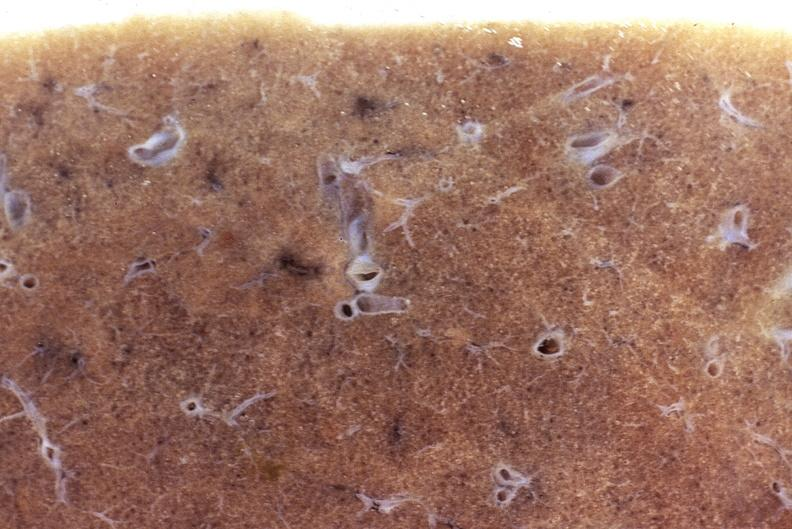s respiratory present?
Answer the question using a single word or phrase. Yes 